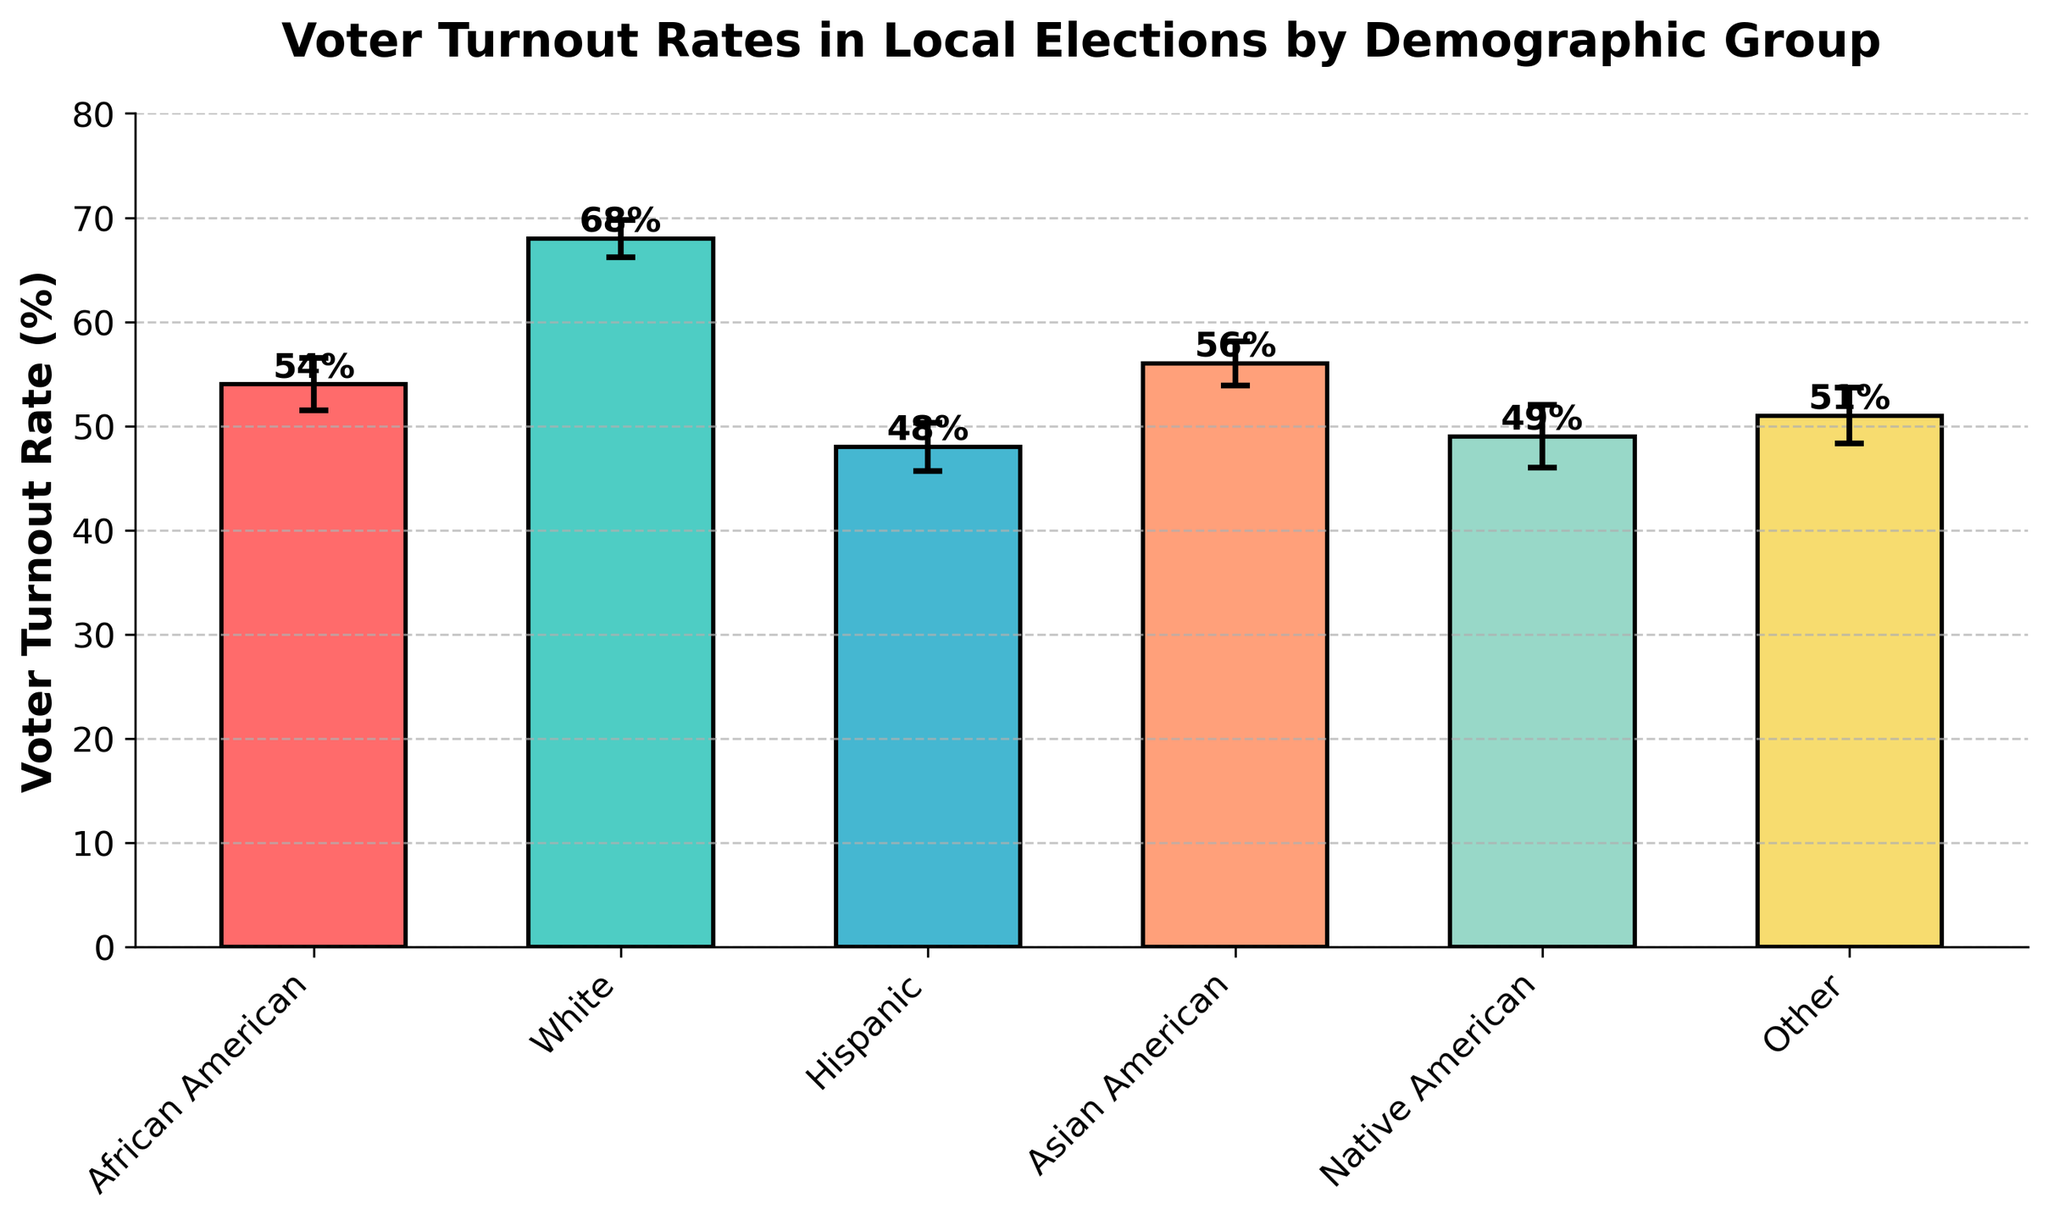What is the title of the bar chart? The title of the chart is usually displayed at the top. Here, it reads "Voter Turnout Rates in Local Elections by Demographic Group".
Answer: Voter Turnout Rates in Local Elections by Demographic Group Which demographic group has the highest voter turnout rate? To determine this, we look at the height of the bars. The bar for "White" is the highest at 68%.
Answer: White How much higher is the voter turnout rate for Asian Americans compared to Hispanics? The turnout for Asian Americans is 56%, and for Hispanics, it is 48%. Subtracting 48 from 56 gives us a difference of 8%.
Answer: 8% Which demographic group has the lowest voter turnout rate and what is it? By observing the heights of the bars, the "Hispanic" group has the lowest turnout rate at 48%.
Answer: Hispanic with 48% What is the margin of error for the Native American demographic group? Margins of error are represented by the error bars on top of each bar. For Native Americans, it is 3.0%.
Answer: 3.0% How does the voter turnout rate for African Americans compare to that for Asian Americans, including margins of error? The voter turnout rate for African Americans is 54% with a margin of error of 2.5%. For Asian Americans, it is 56% with a margin of error of 2.1%. Considering the margins of error, the ranges overlap (African Americans: 51.5-56.5%, Asian Americans: 53.9-58.1%), so the differences are not statistically significant.
Answer: Overlapping margin of error What is the average voter turnout rate across all demographic groups? To find this, sum all voter turnout rates (54 + 68 + 48 + 56 + 49 + 51) and divide by the number of groups, which is 6. (54 + 68 + 48 + 56 + 49 + 51) / 6 = 54.33%.
Answer: 54.33% Which two demographic groups have the closest voter turnout rates, and what are they? By comparing the heights of the bars, African American (54%) and Other (51%) have the closest voter turnout rates with a difference of 3%.
Answer: African American and Other What is the range of voter turnout rates for the listed demographic groups? The range is calculated by subtracting the smallest turnout rate from the highest. The highest is 68% (White) and the lowest is 48% (Hispanic). So, 68% - 48% = 20%.
Answer: 20% How would you describe the variability of the voter turnout rates based on margins of error? Observing the size of the error bars, we can infer the variability. Larger error bars indicate higher variability. Native Americans have the largest margin of error at 3.0%, suggesting more variability, while Whites have the lowest margin of error at 1.8%, indicating less variability.
Answer: Native Americans have the highest variability, Whites have the lowest 